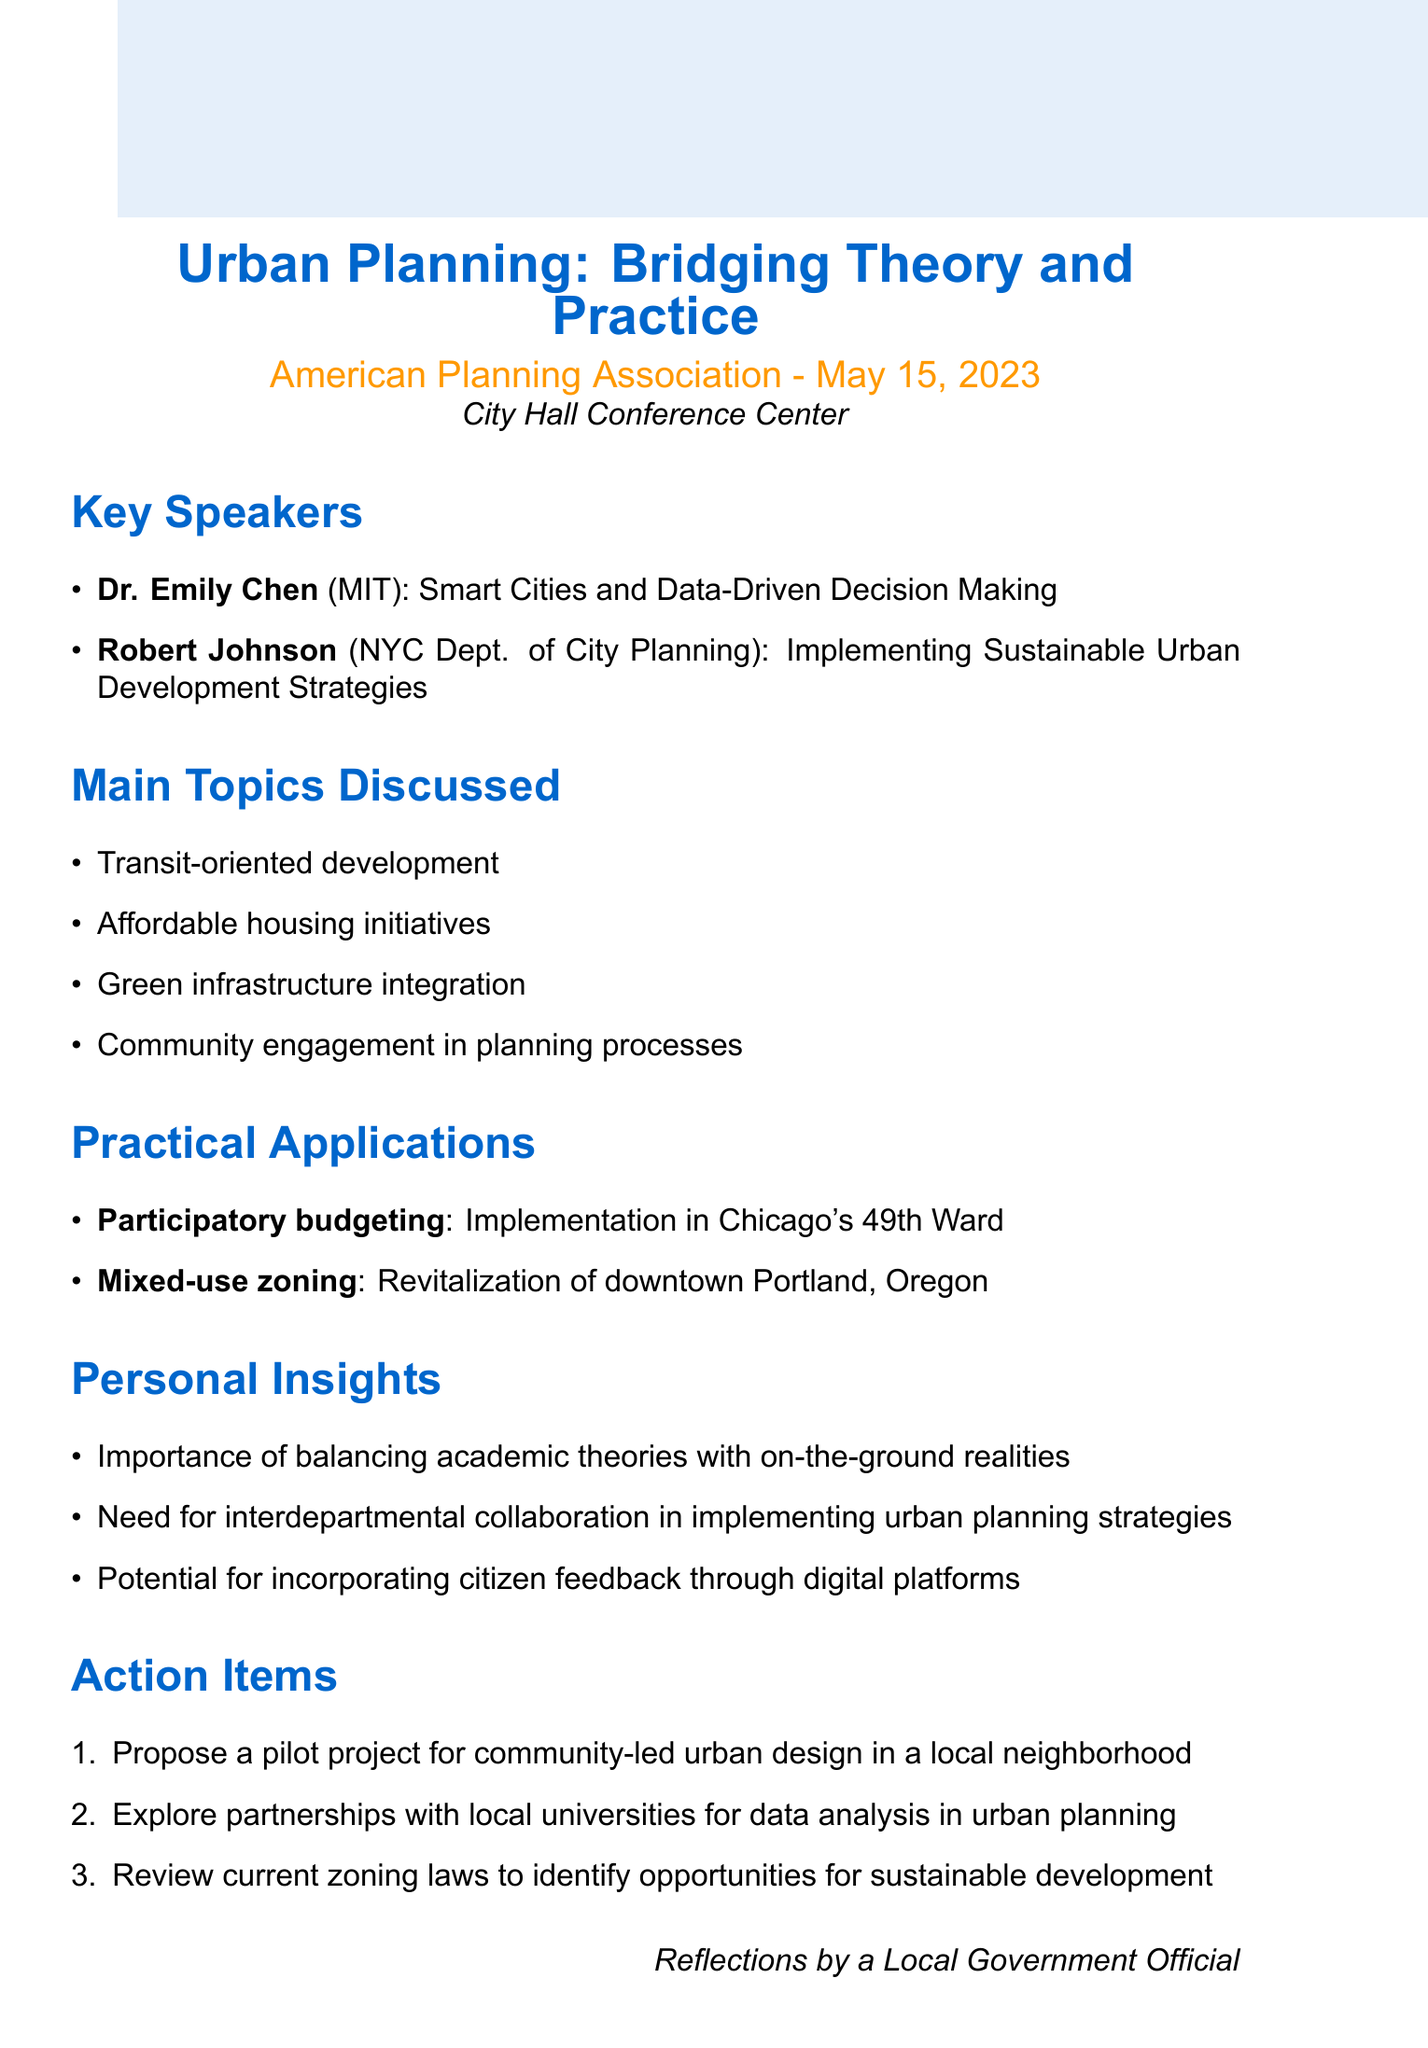What is the title of the seminar? The title of the seminar is "Urban Planning: Bridging Theory and Practice".
Answer: Urban Planning: Bridging Theory and Practice Who is the organizer of the seminar? The organizer of the seminar is the American Planning Association.
Answer: American Planning Association When was the seminar held? The seminar was held on May 15, 2023.
Answer: May 15, 2023 What is one of the main topics discussed? One of the main topics discussed is "Affordable housing initiatives".
Answer: Affordable housing initiatives What is the focus of Dr. Emily Chen's presentation? Dr. Emily Chen's presentation focuses on "Smart Cities and Data-Driven Decision Making".
Answer: Smart Cities and Data-Driven Decision Making Which local example is associated with participatory budgeting? The local example associated with participatory budgeting is "Implementation in Chicago's 49th Ward".
Answer: Implementation in Chicago's 49th Ward What is a proposed action item related to urban design? A proposed action item related to urban design is to "Propose a pilot project for community-led urban design in a local neighborhood".
Answer: Propose a pilot project for community-led urban design in a local neighborhood What personal insight highlights the need for collaboration? A personal insight that highlights the need for collaboration is "Need for interdepartmental collaboration in implementing urban planning strategies".
Answer: Need for interdepartmental collaboration in implementing urban planning strategies What type of zoning is associated with revitalizing downtown Portland? The type of zoning associated with revitalizing downtown Portland is "Mixed-use zoning".
Answer: Mixed-use zoning 